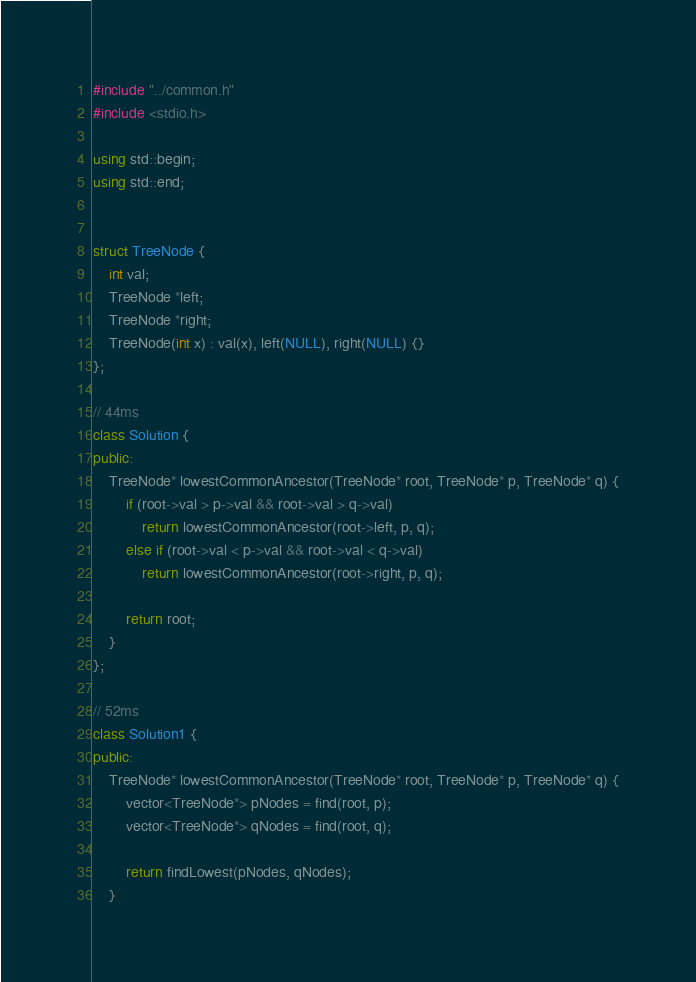<code> <loc_0><loc_0><loc_500><loc_500><_C++_>#include "../common.h"
#include <stdio.h>

using std::begin;
using std::end;


struct TreeNode {
    int val;
    TreeNode *left;
    TreeNode *right;
    TreeNode(int x) : val(x), left(NULL), right(NULL) {}
};

// 44ms
class Solution {
public:
    TreeNode* lowestCommonAncestor(TreeNode* root, TreeNode* p, TreeNode* q) {
        if (root->val > p->val && root->val > q->val)
            return lowestCommonAncestor(root->left, p, q);
        else if (root->val < p->val && root->val < q->val)
            return lowestCommonAncestor(root->right, p, q);
        
        return root;
    }
};

// 52ms
class Solution1 {
public:
    TreeNode* lowestCommonAncestor(TreeNode* root, TreeNode* p, TreeNode* q) {
        vector<TreeNode*> pNodes = find(root, p);
        vector<TreeNode*> qNodes = find(root, q);
        
        return findLowest(pNodes, qNodes);
    }
</code> 